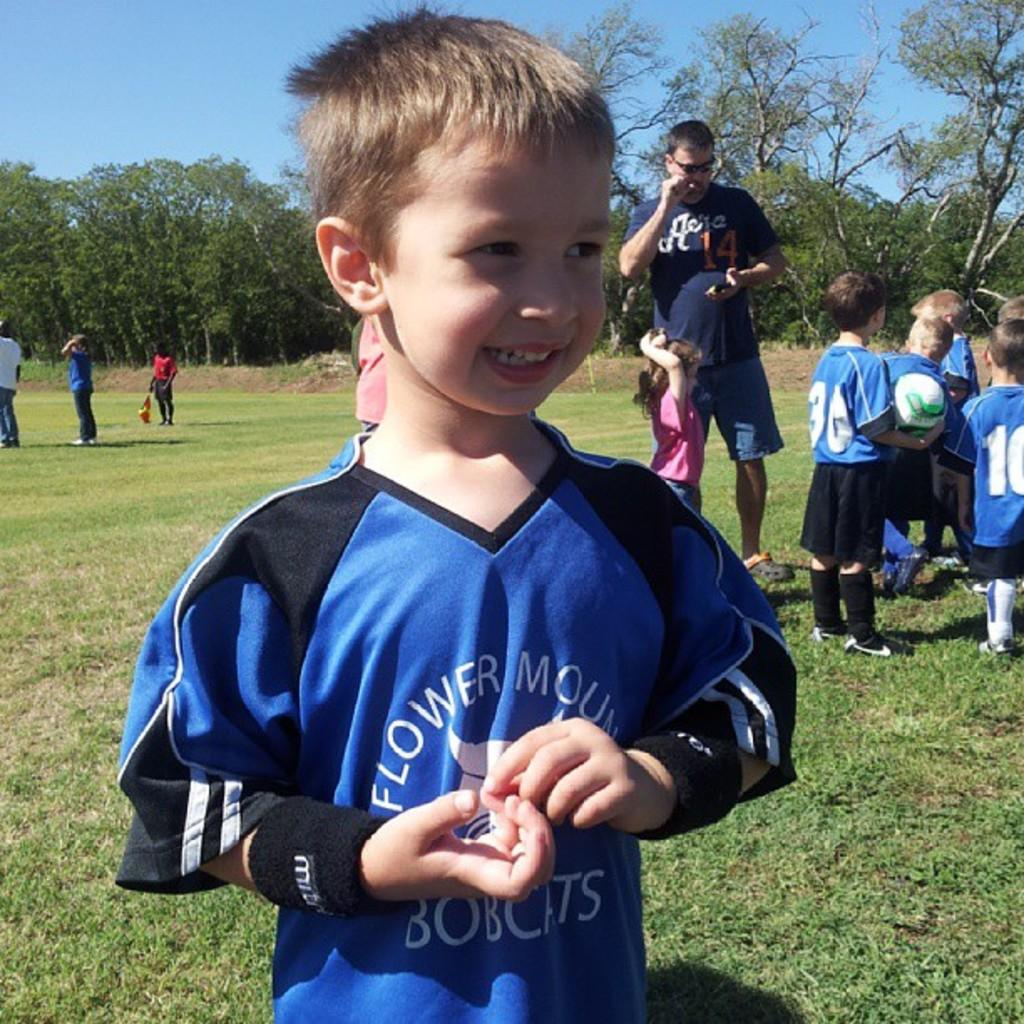<image>
Relay a brief, clear account of the picture shown. A young boy, wearing a blue Bobcats jersey, is smiling. 